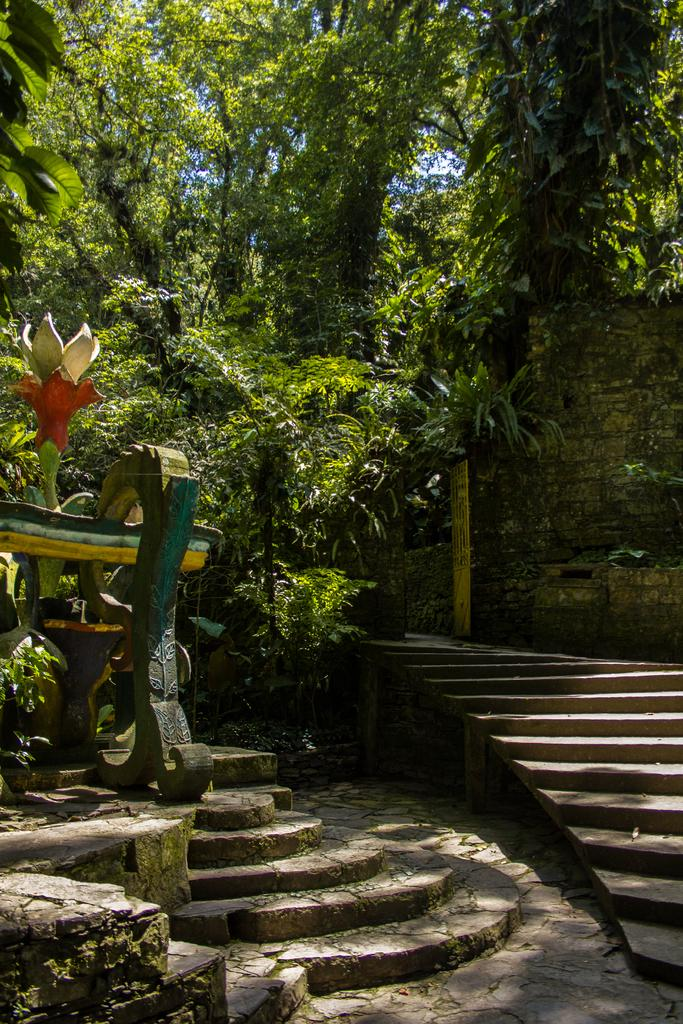What can be seen in the foreground of the image? There are steps in the foreground of the image. What is visible in the background of the image? There are trees and a wall in the background of the image. How many feet are visible on the steps in the image? There are no feet visible on the steps in the image. What type of stem can be seen growing from the wall in the image? There is no stem growing from the wall in the image. 